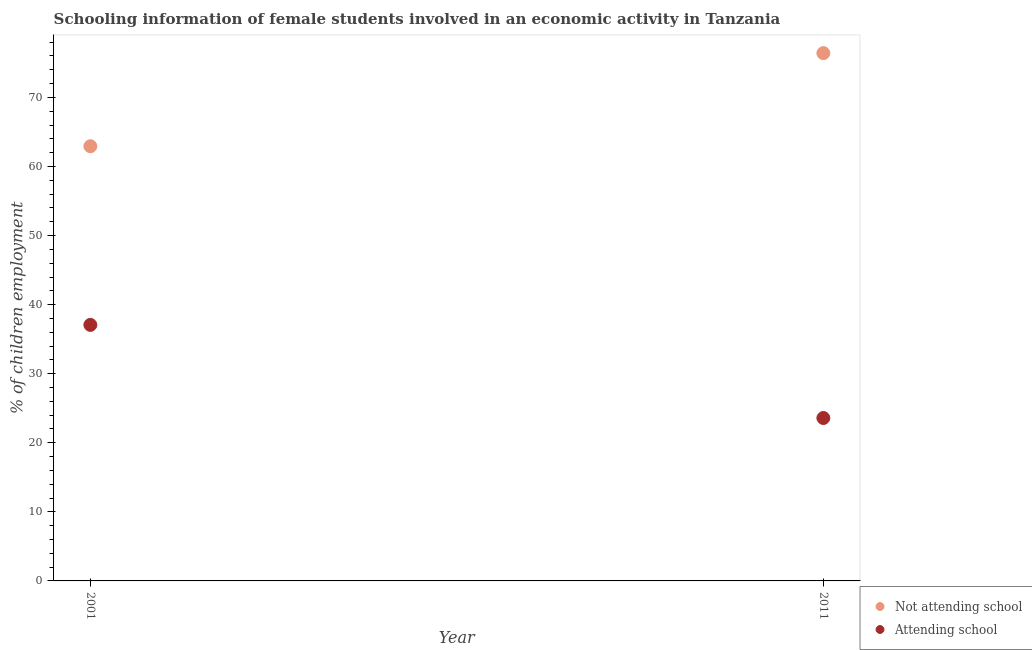What is the percentage of employed females who are attending school in 2001?
Keep it short and to the point. 37.07. Across all years, what is the maximum percentage of employed females who are attending school?
Offer a very short reply. 37.07. Across all years, what is the minimum percentage of employed females who are attending school?
Your answer should be very brief. 23.59. What is the total percentage of employed females who are attending school in the graph?
Provide a succinct answer. 60.65. What is the difference between the percentage of employed females who are attending school in 2001 and that in 2011?
Provide a succinct answer. 13.48. What is the difference between the percentage of employed females who are not attending school in 2011 and the percentage of employed females who are attending school in 2001?
Your response must be concise. 39.35. What is the average percentage of employed females who are attending school per year?
Give a very brief answer. 30.33. In the year 2011, what is the difference between the percentage of employed females who are attending school and percentage of employed females who are not attending school?
Provide a short and direct response. -52.83. In how many years, is the percentage of employed females who are not attending school greater than 62 %?
Your response must be concise. 2. What is the ratio of the percentage of employed females who are not attending school in 2001 to that in 2011?
Offer a terse response. 0.82. Is the percentage of employed females who are not attending school strictly greater than the percentage of employed females who are attending school over the years?
Your answer should be very brief. Yes. How many dotlines are there?
Offer a very short reply. 2. What is the difference between two consecutive major ticks on the Y-axis?
Your response must be concise. 10. Does the graph contain any zero values?
Your response must be concise. No. Does the graph contain grids?
Give a very brief answer. No. How many legend labels are there?
Your answer should be compact. 2. How are the legend labels stacked?
Ensure brevity in your answer.  Vertical. What is the title of the graph?
Ensure brevity in your answer.  Schooling information of female students involved in an economic activity in Tanzania. What is the label or title of the X-axis?
Offer a very short reply. Year. What is the label or title of the Y-axis?
Provide a succinct answer. % of children employment. What is the % of children employment of Not attending school in 2001?
Make the answer very short. 62.93. What is the % of children employment in Attending school in 2001?
Make the answer very short. 37.07. What is the % of children employment in Not attending school in 2011?
Your answer should be very brief. 76.41. What is the % of children employment of Attending school in 2011?
Offer a terse response. 23.59. Across all years, what is the maximum % of children employment in Not attending school?
Your answer should be compact. 76.41. Across all years, what is the maximum % of children employment of Attending school?
Your answer should be very brief. 37.07. Across all years, what is the minimum % of children employment of Not attending school?
Your response must be concise. 62.93. Across all years, what is the minimum % of children employment in Attending school?
Offer a terse response. 23.59. What is the total % of children employment of Not attending school in the graph?
Offer a terse response. 139.35. What is the total % of children employment in Attending school in the graph?
Provide a short and direct response. 60.65. What is the difference between the % of children employment in Not attending school in 2001 and that in 2011?
Your answer should be compact. -13.48. What is the difference between the % of children employment of Attending school in 2001 and that in 2011?
Keep it short and to the point. 13.48. What is the difference between the % of children employment in Not attending school in 2001 and the % of children employment in Attending school in 2011?
Keep it short and to the point. 39.35. What is the average % of children employment of Not attending school per year?
Your answer should be compact. 69.67. What is the average % of children employment in Attending school per year?
Your response must be concise. 30.33. In the year 2001, what is the difference between the % of children employment in Not attending school and % of children employment in Attending school?
Offer a terse response. 25.87. In the year 2011, what is the difference between the % of children employment of Not attending school and % of children employment of Attending school?
Provide a succinct answer. 52.83. What is the ratio of the % of children employment of Not attending school in 2001 to that in 2011?
Provide a short and direct response. 0.82. What is the ratio of the % of children employment in Attending school in 2001 to that in 2011?
Give a very brief answer. 1.57. What is the difference between the highest and the second highest % of children employment in Not attending school?
Your response must be concise. 13.48. What is the difference between the highest and the second highest % of children employment in Attending school?
Ensure brevity in your answer.  13.48. What is the difference between the highest and the lowest % of children employment of Not attending school?
Your answer should be very brief. 13.48. What is the difference between the highest and the lowest % of children employment of Attending school?
Offer a terse response. 13.48. 